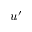<formula> <loc_0><loc_0><loc_500><loc_500>u ^ { \prime }</formula> 